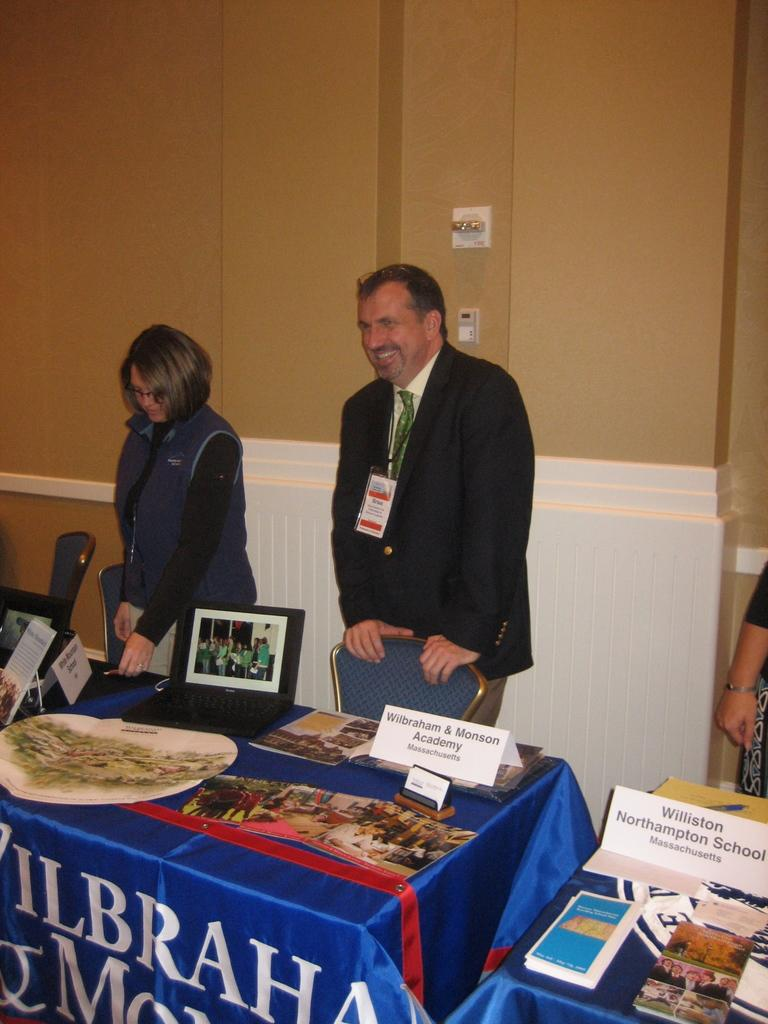<image>
Share a concise interpretation of the image provided. Man standing in front of a table with a sign for "Wilbraham & Monson Academy". 